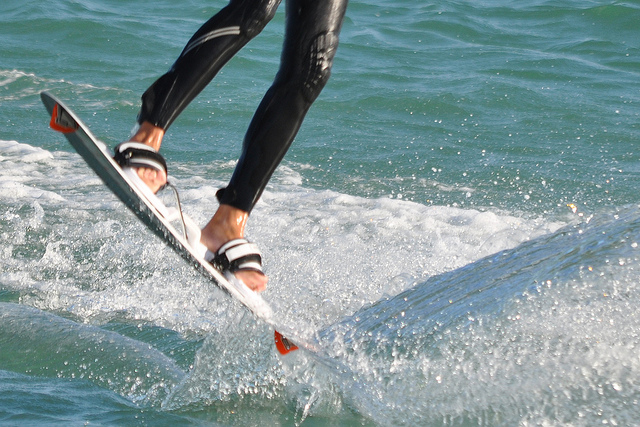Is it summer? While it's not possible to determine the exact season from the image alone, the bright sunlight and the person engaging in water sports suggest it could be summer, which is a popular season for such activities. 